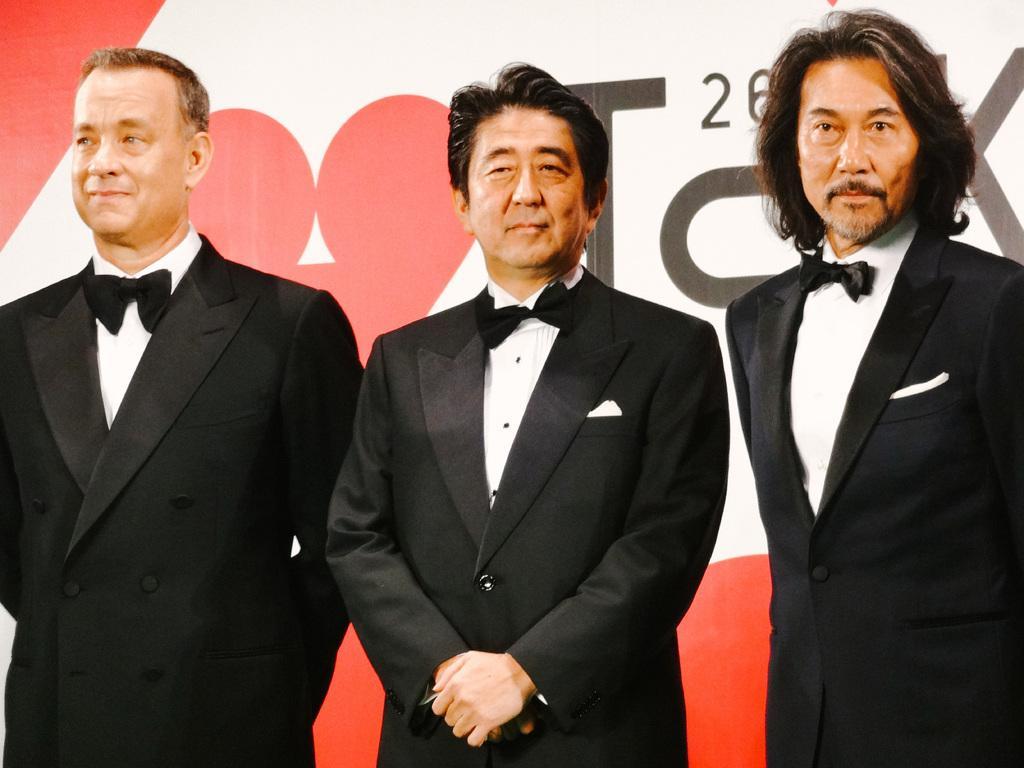How would you summarize this image in a sentence or two? In this image we can see men standing on the floor. In the background there is an advertisement. 